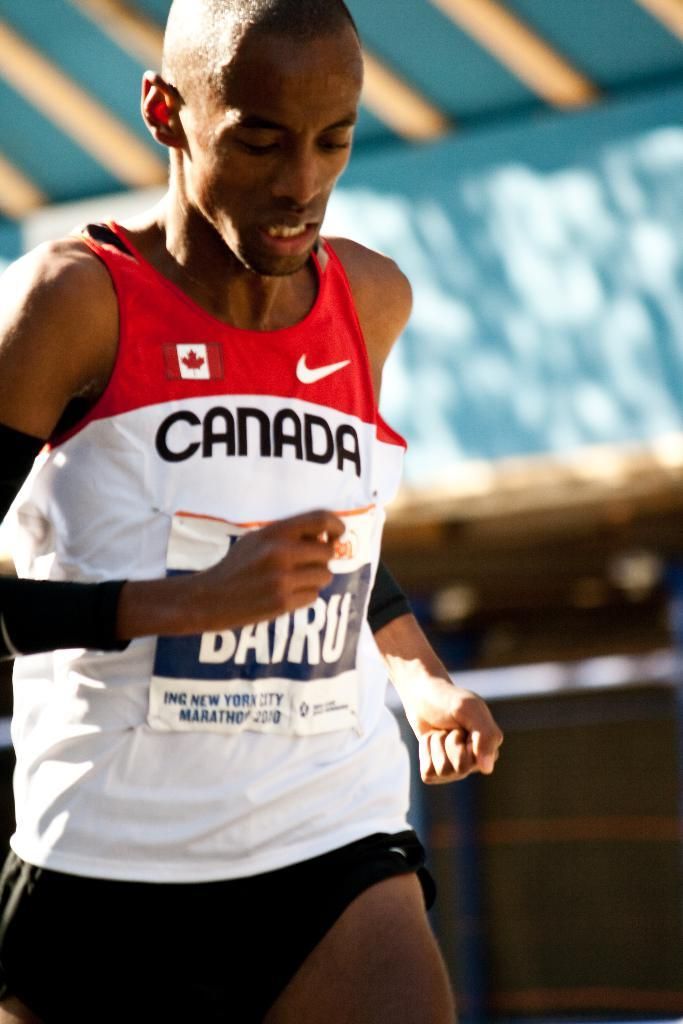<image>
Offer a succinct explanation of the picture presented. a person running with the word canada on their shirt 